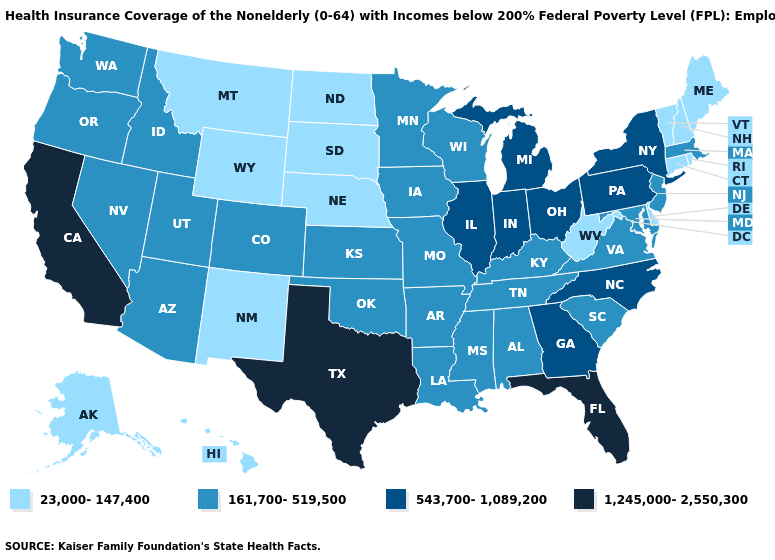Does North Dakota have the highest value in the USA?
Answer briefly. No. Which states have the lowest value in the MidWest?
Short answer required. Nebraska, North Dakota, South Dakota. What is the highest value in the USA?
Keep it brief. 1,245,000-2,550,300. Among the states that border West Virginia , does Pennsylvania have the lowest value?
Give a very brief answer. No. What is the value of Alaska?
Quick response, please. 23,000-147,400. Name the states that have a value in the range 543,700-1,089,200?
Keep it brief. Georgia, Illinois, Indiana, Michigan, New York, North Carolina, Ohio, Pennsylvania. What is the highest value in the West ?
Short answer required. 1,245,000-2,550,300. Name the states that have a value in the range 1,245,000-2,550,300?
Short answer required. California, Florida, Texas. What is the lowest value in states that border New Mexico?
Quick response, please. 161,700-519,500. Name the states that have a value in the range 1,245,000-2,550,300?
Short answer required. California, Florida, Texas. Name the states that have a value in the range 161,700-519,500?
Short answer required. Alabama, Arizona, Arkansas, Colorado, Idaho, Iowa, Kansas, Kentucky, Louisiana, Maryland, Massachusetts, Minnesota, Mississippi, Missouri, Nevada, New Jersey, Oklahoma, Oregon, South Carolina, Tennessee, Utah, Virginia, Washington, Wisconsin. Does the map have missing data?
Give a very brief answer. No. Is the legend a continuous bar?
Concise answer only. No. Does the first symbol in the legend represent the smallest category?
Quick response, please. Yes. 